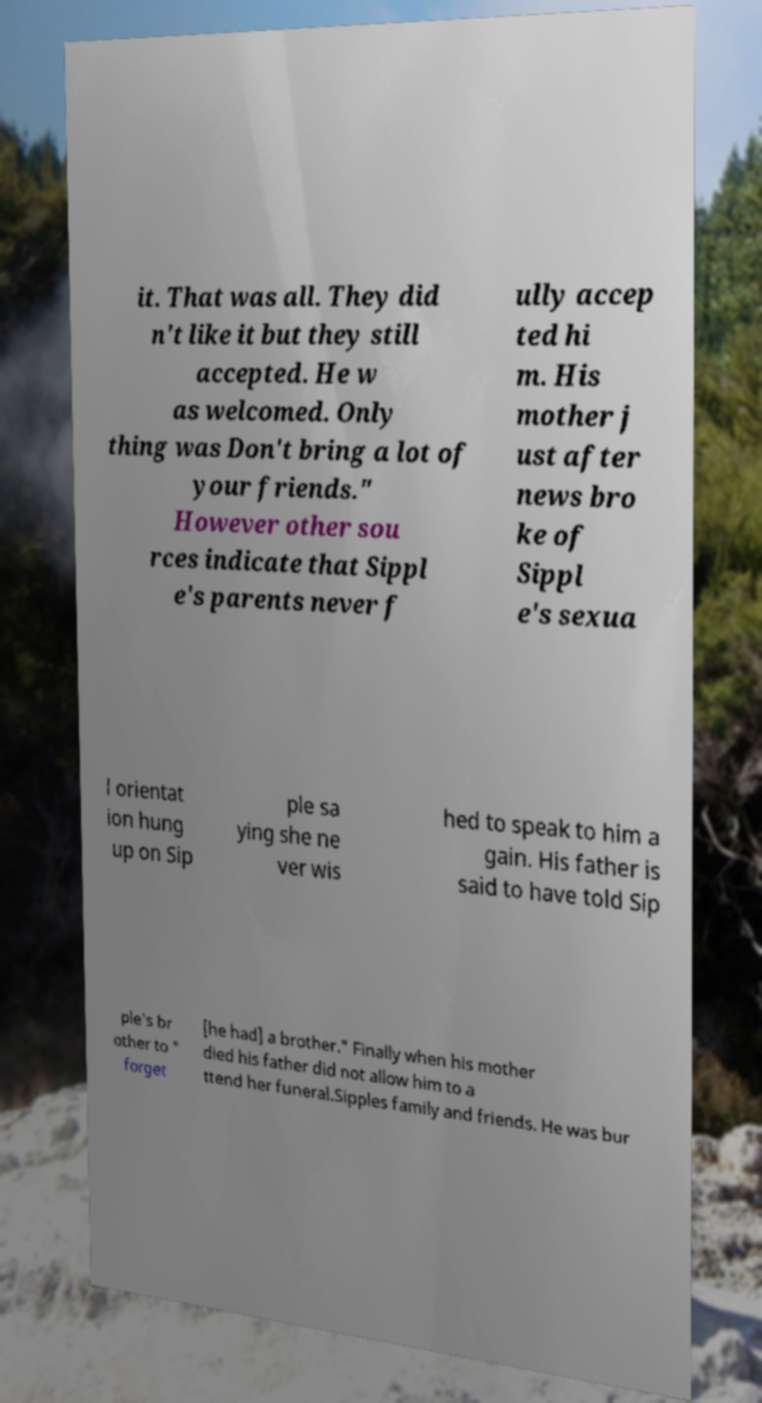There's text embedded in this image that I need extracted. Can you transcribe it verbatim? it. That was all. They did n't like it but they still accepted. He w as welcomed. Only thing was Don't bring a lot of your friends." However other sou rces indicate that Sippl e's parents never f ully accep ted hi m. His mother j ust after news bro ke of Sippl e's sexua l orientat ion hung up on Sip ple sa ying she ne ver wis hed to speak to him a gain. His father is said to have told Sip ple's br other to " forget [he had] a brother." Finally when his mother died his father did not allow him to a ttend her funeral.Sipples family and friends. He was bur 